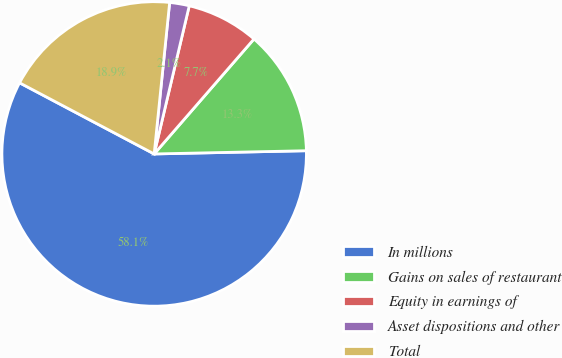<chart> <loc_0><loc_0><loc_500><loc_500><pie_chart><fcel>In millions<fcel>Gains on sales of restaurant<fcel>Equity in earnings of<fcel>Asset dispositions and other<fcel>Total<nl><fcel>58.07%<fcel>13.28%<fcel>7.68%<fcel>2.08%<fcel>18.88%<nl></chart> 